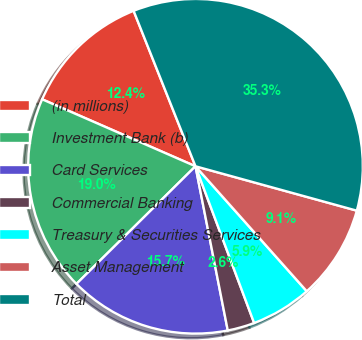Convert chart to OTSL. <chart><loc_0><loc_0><loc_500><loc_500><pie_chart><fcel>(in millions)<fcel>Investment Bank (b)<fcel>Card Services<fcel>Commercial Banking<fcel>Treasury & Securities Services<fcel>Asset Management<fcel>Total<nl><fcel>12.42%<fcel>18.96%<fcel>15.69%<fcel>2.61%<fcel>5.88%<fcel>9.15%<fcel>35.31%<nl></chart> 